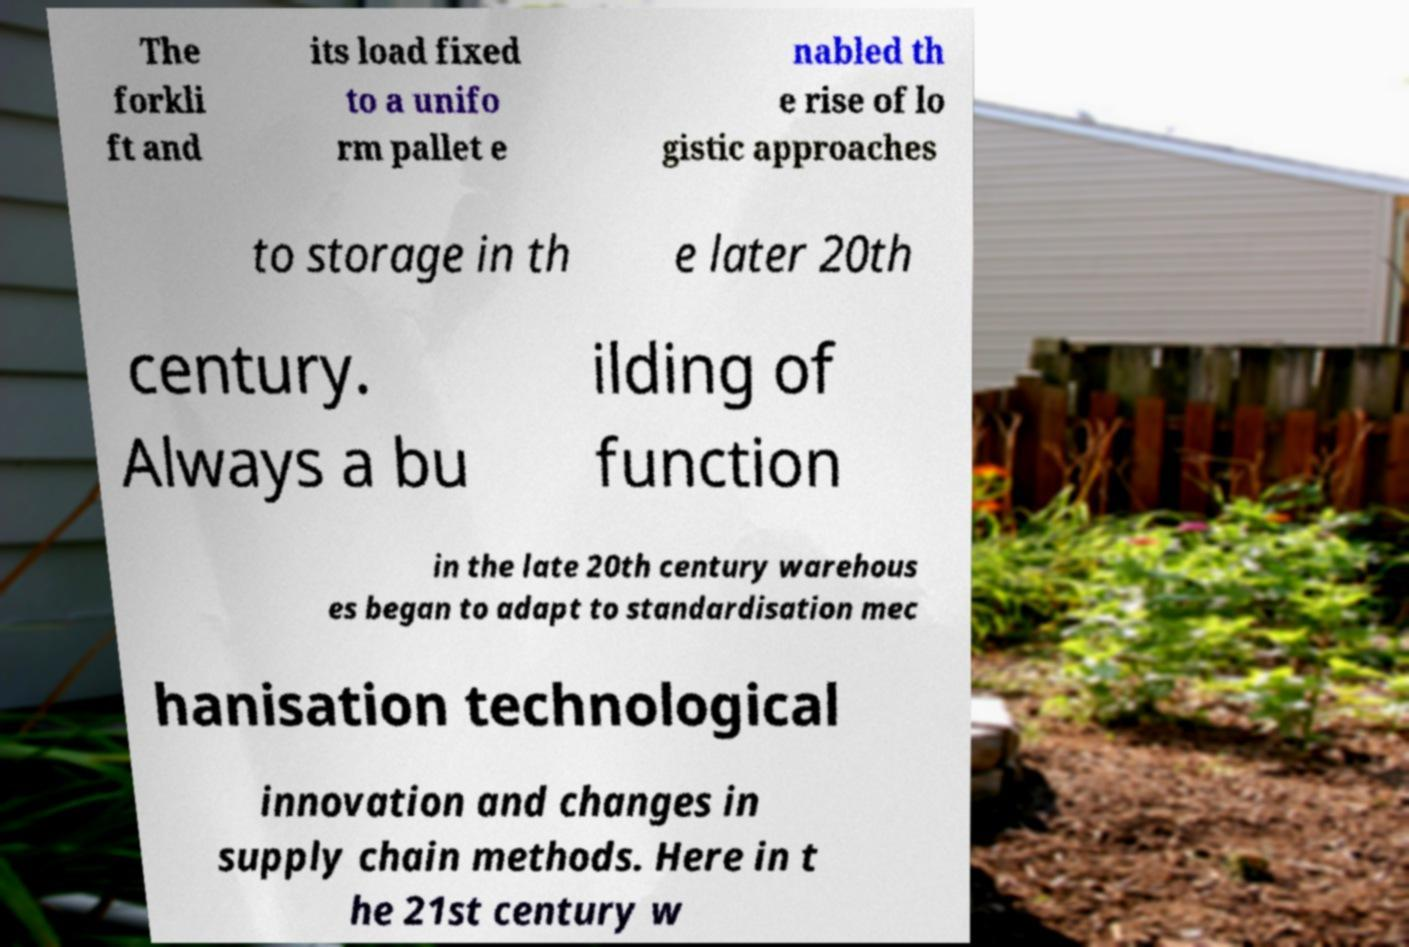There's text embedded in this image that I need extracted. Can you transcribe it verbatim? The forkli ft and its load fixed to a unifo rm pallet e nabled th e rise of lo gistic approaches to storage in th e later 20th century. Always a bu ilding of function in the late 20th century warehous es began to adapt to standardisation mec hanisation technological innovation and changes in supply chain methods. Here in t he 21st century w 